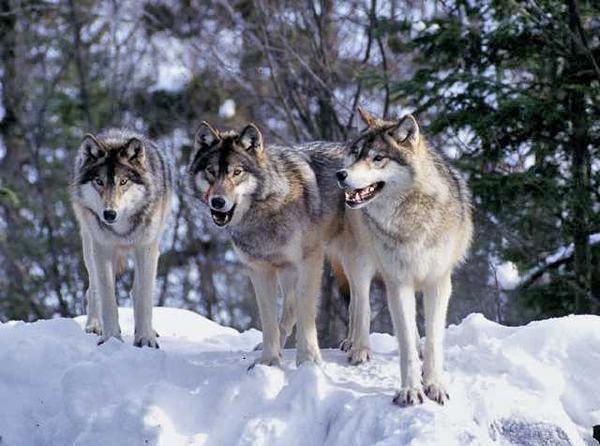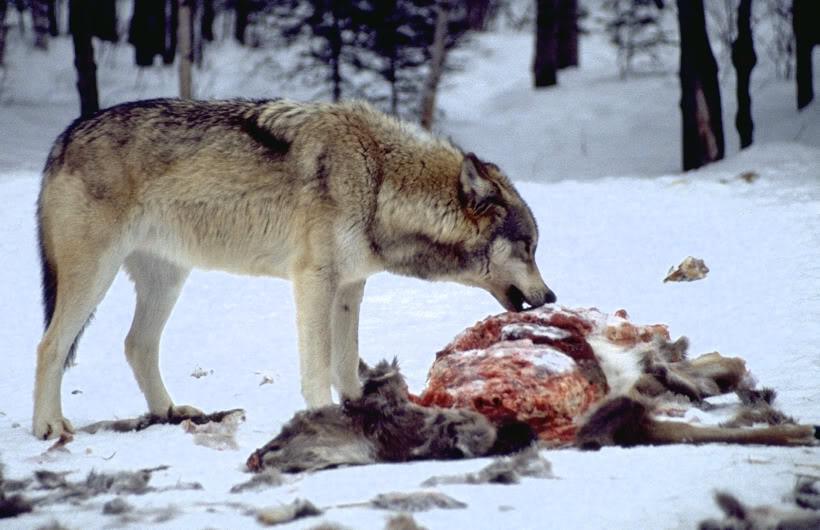The first image is the image on the left, the second image is the image on the right. Analyze the images presented: Is the assertion "Three wild dogs are in the snow in the image on the left." valid? Answer yes or no. Yes. The first image is the image on the left, the second image is the image on the right. For the images shown, is this caption "An image shows wolves bounding across the snow." true? Answer yes or no. No. 